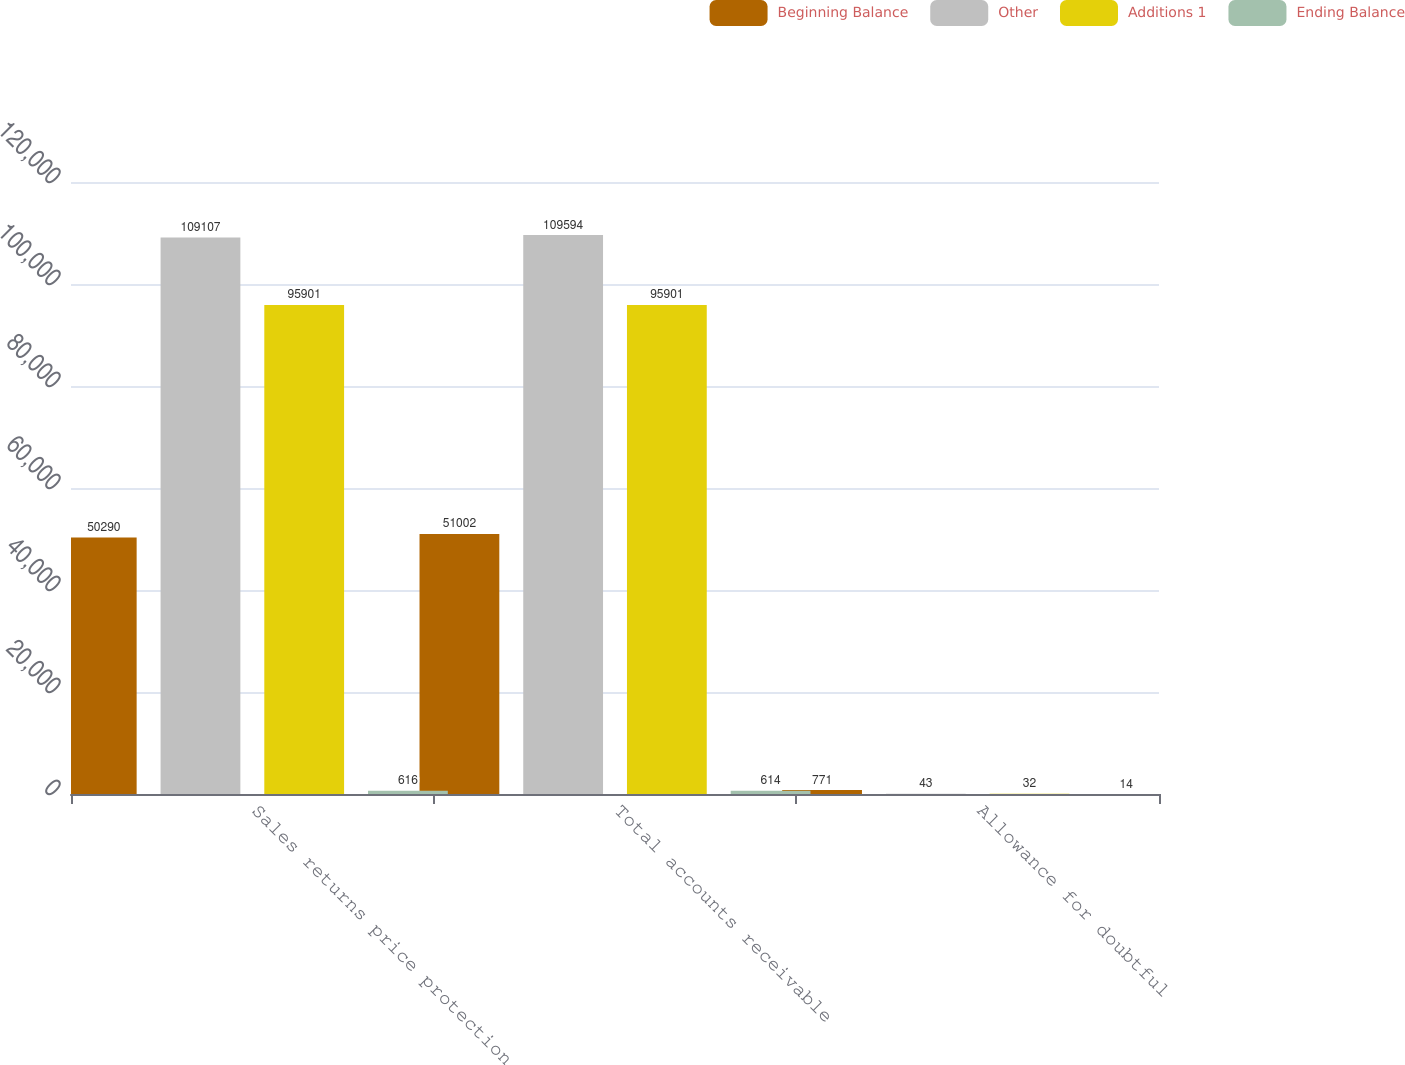<chart> <loc_0><loc_0><loc_500><loc_500><stacked_bar_chart><ecel><fcel>Sales returns price protection<fcel>Total accounts receivable<fcel>Allowance for doubtful<nl><fcel>Beginning Balance<fcel>50290<fcel>51002<fcel>771<nl><fcel>Other<fcel>109107<fcel>109594<fcel>43<nl><fcel>Additions 1<fcel>95901<fcel>95901<fcel>32<nl><fcel>Ending Balance<fcel>616<fcel>614<fcel>14<nl></chart> 